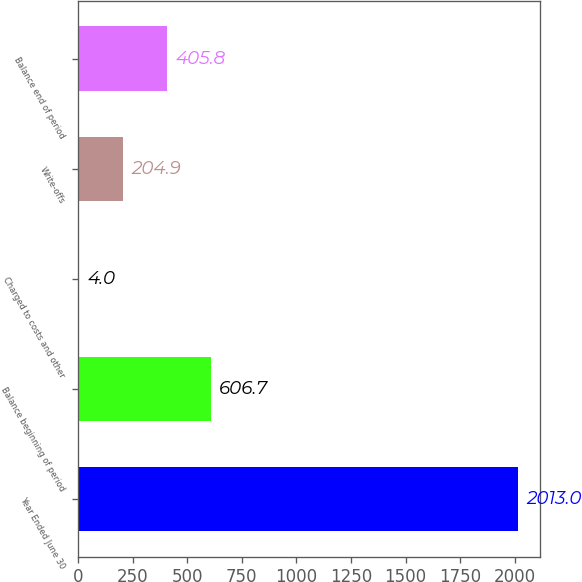Convert chart to OTSL. <chart><loc_0><loc_0><loc_500><loc_500><bar_chart><fcel>Year Ended June 30<fcel>Balance beginning of period<fcel>Charged to costs and other<fcel>Write-offs<fcel>Balance end of period<nl><fcel>2013<fcel>606.7<fcel>4<fcel>204.9<fcel>405.8<nl></chart> 